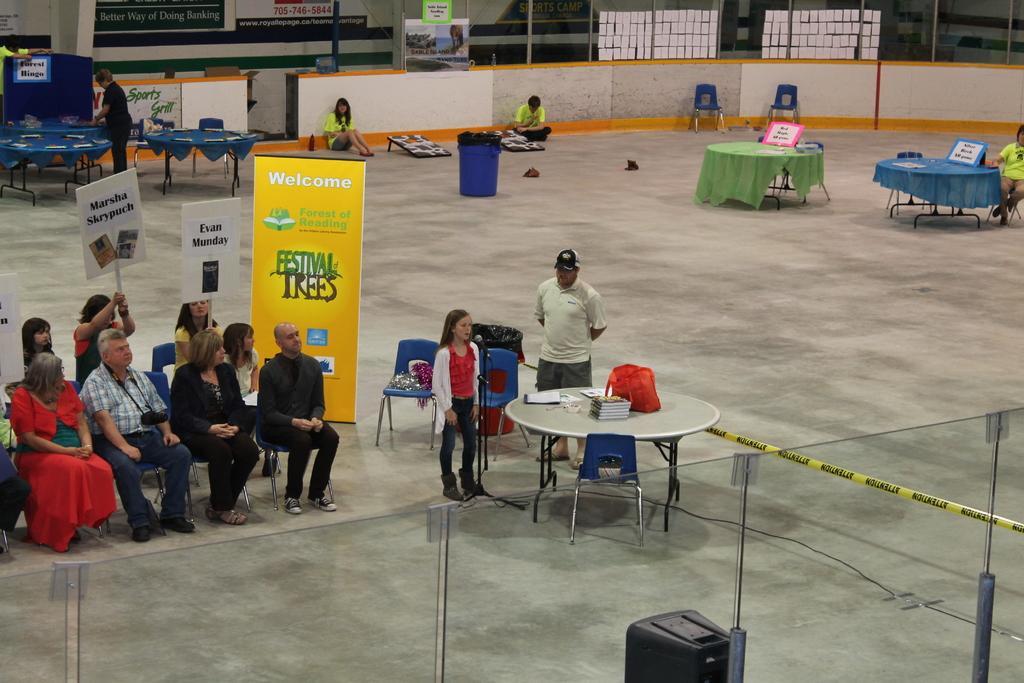Describe this image in one or two sentences. In this image there are group of people who are sitting on a chair and holding a pluck card. In the middle there is a table and a chair and on the table there are bag and books. In the background there are two people sitting on the floor. To the right side there is a table on which there is a card kept on it. To the left side there is a person who is working on the table. In the middle there is a dustbin. 